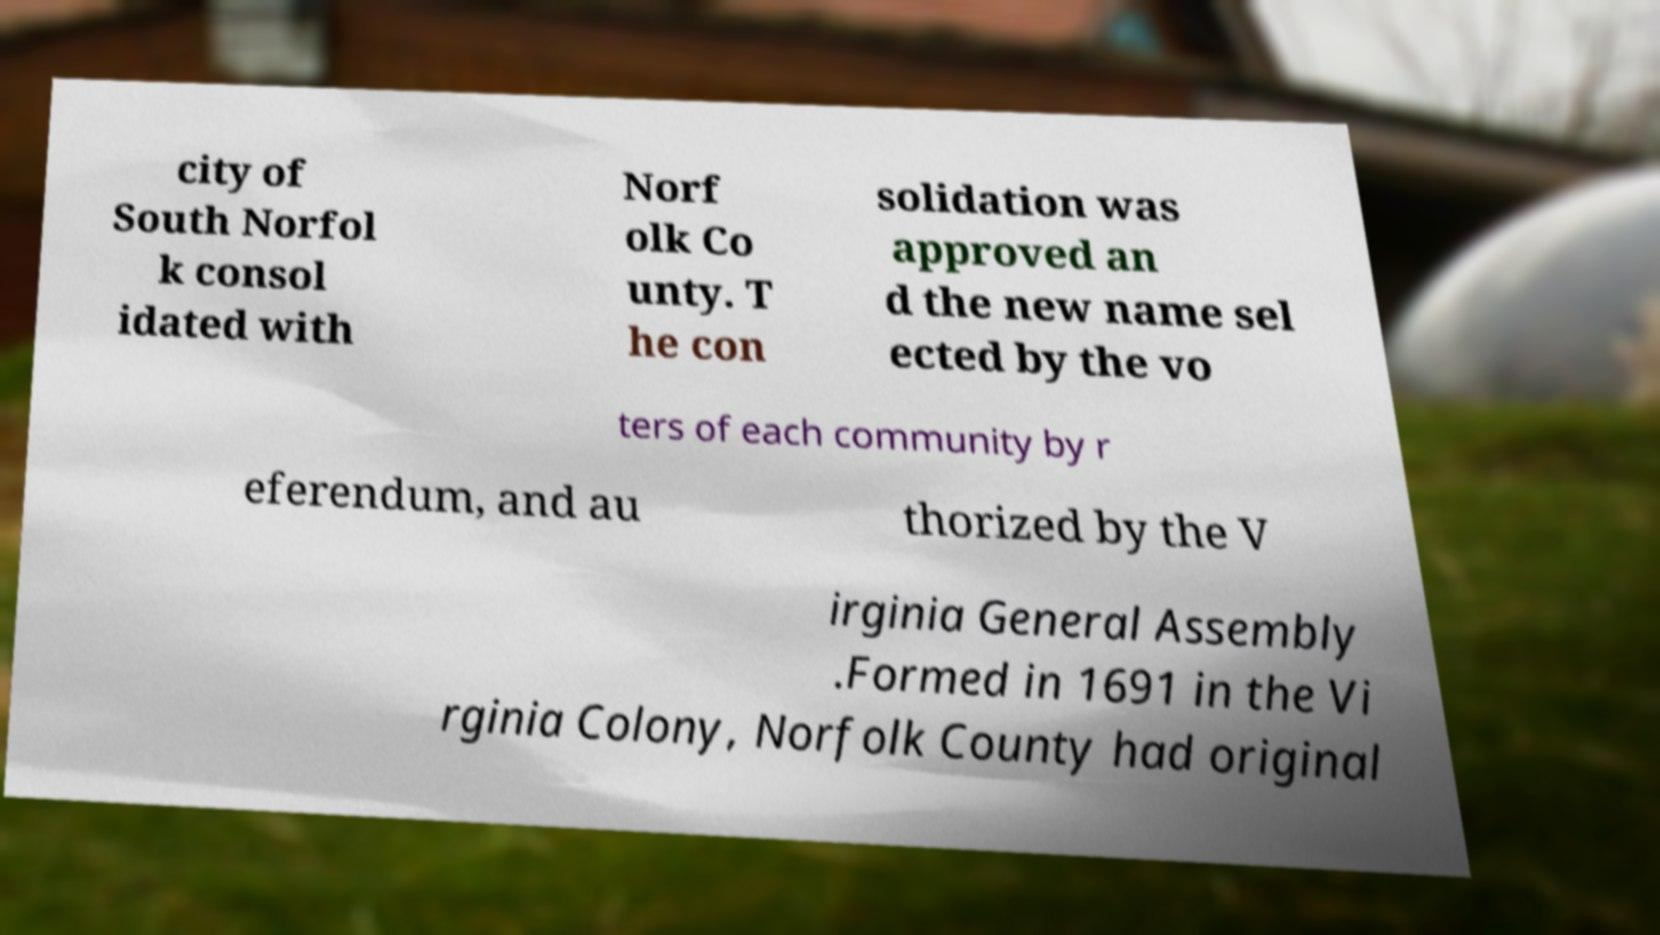Can you read and provide the text displayed in the image?This photo seems to have some interesting text. Can you extract and type it out for me? city of South Norfol k consol idated with Norf olk Co unty. T he con solidation was approved an d the new name sel ected by the vo ters of each community by r eferendum, and au thorized by the V irginia General Assembly .Formed in 1691 in the Vi rginia Colony, Norfolk County had original 